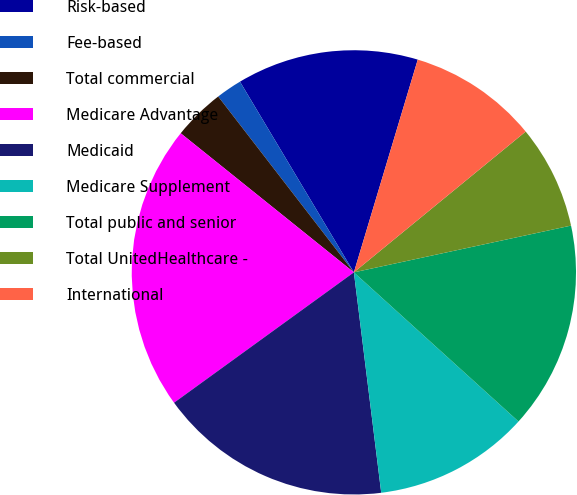Convert chart to OTSL. <chart><loc_0><loc_0><loc_500><loc_500><pie_chart><fcel>Risk-based<fcel>Fee-based<fcel>Total commercial<fcel>Medicare Advantage<fcel>Medicaid<fcel>Medicare Supplement<fcel>Total public and senior<fcel>Total UnitedHealthcare -<fcel>International<nl><fcel>13.21%<fcel>1.89%<fcel>3.77%<fcel>20.75%<fcel>16.98%<fcel>11.32%<fcel>15.09%<fcel>7.55%<fcel>9.43%<nl></chart> 